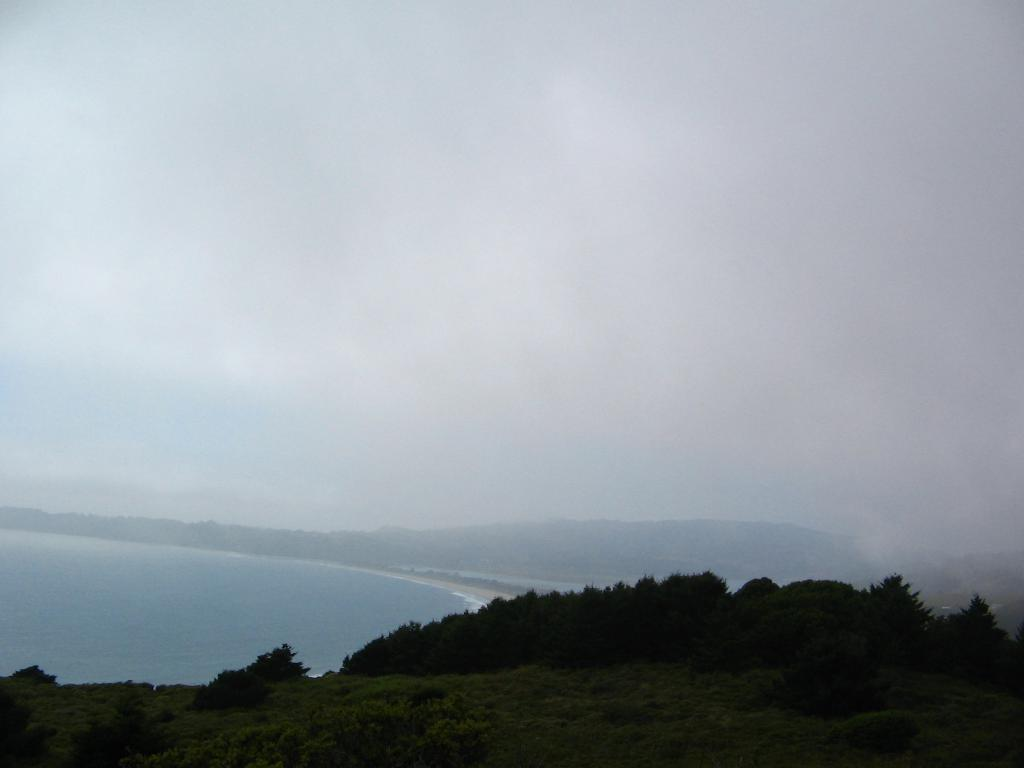What type of vegetation can be seen in the image? There are trees in the image. What body of water is visible on the left side of the image? There is an ocean on the left side of the image. What type of landscape feature is present in the background of the image? There are hills in the background of the image. What is visible in the sky in the background of the image? The sky is visible in the background of the image, and there are clouds present. Where is the flame located in the image? There is no flame present in the image. What type of experience can be gained from the image? The image itself does not provide an experience, but it may evoke feelings or memories related to nature or the outdoors. 